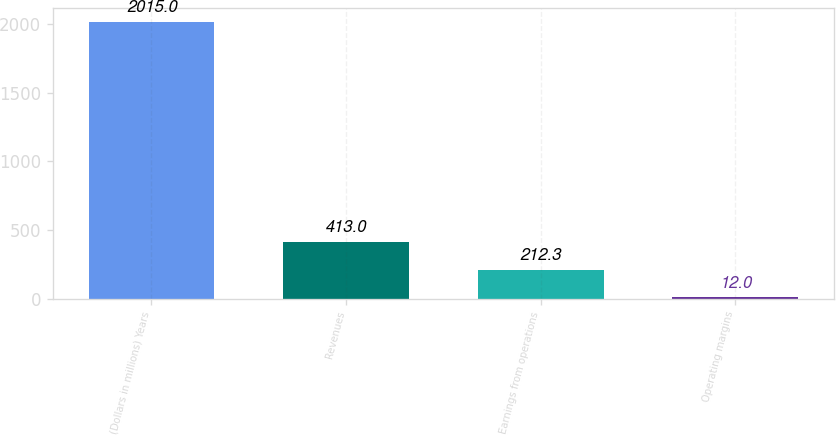<chart> <loc_0><loc_0><loc_500><loc_500><bar_chart><fcel>(Dollars in millions) Years<fcel>Revenues<fcel>Earnings from operations<fcel>Operating margins<nl><fcel>2015<fcel>413<fcel>212.3<fcel>12<nl></chart> 